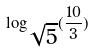<formula> <loc_0><loc_0><loc_500><loc_500>\log _ { \sqrt { 5 } } ( \frac { 1 0 } { 3 } )</formula> 